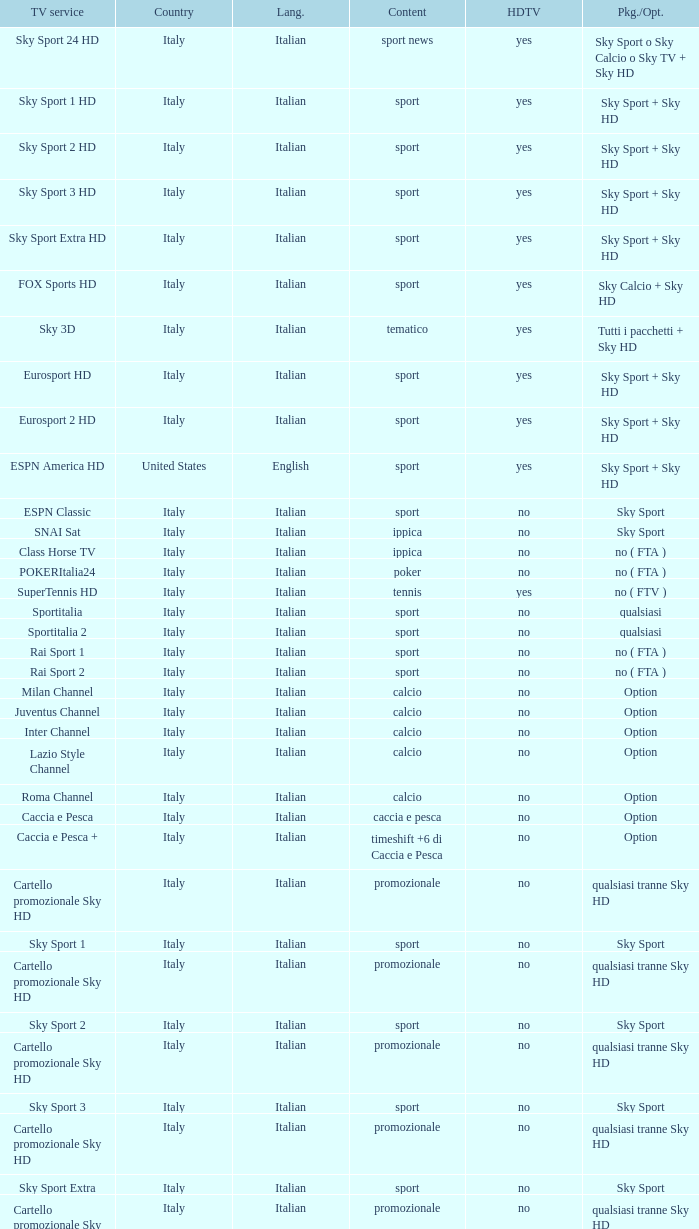What is Language, when Content is Sport, when HDTV is No, and when Television Service is ESPN America? Italian. 